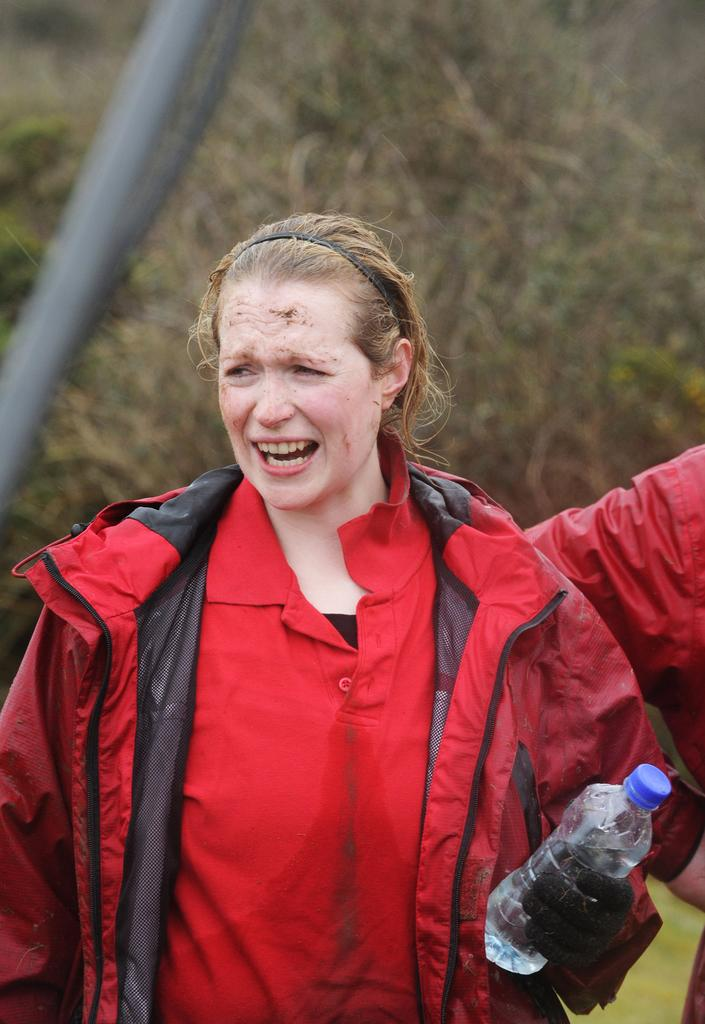Who is the main subject in the image? There is a woman in the image. What is the woman wearing? The woman is wearing a red jacket. What is the woman holding in the image? The woman is holding a bottle. Can you describe the woman's expression? The woman is giving a specific expression. What can be seen in the background of the image? There are trees in the background of the image. What type of tax is the woman discussing in the image? There is no indication in the image that the woman is discussing any type of tax. 